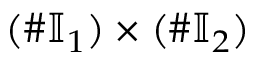Convert formula to latex. <formula><loc_0><loc_0><loc_500><loc_500>( \# \mathbb { I } _ { 1 } ) \times ( \# \mathbb { I } _ { 2 } )</formula> 